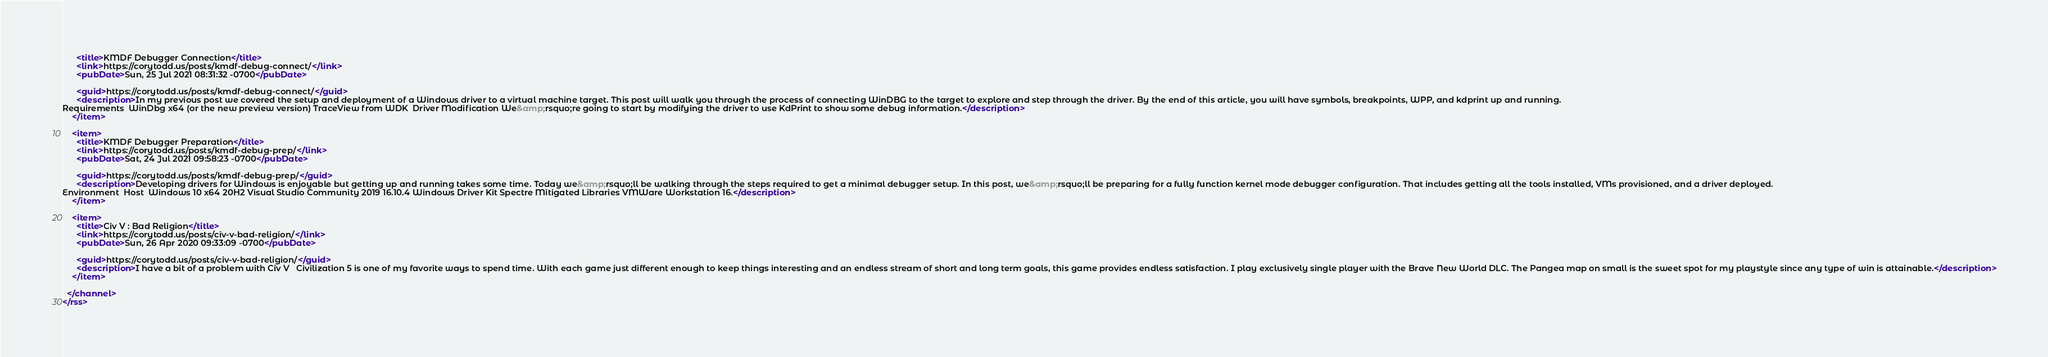<code> <loc_0><loc_0><loc_500><loc_500><_XML_>      <title>KMDF Debugger Connection</title>
      <link>https://corytodd.us/posts/kmdf-debug-connect/</link>
      <pubDate>Sun, 25 Jul 2021 08:31:32 -0700</pubDate>
      
      <guid>https://corytodd.us/posts/kmdf-debug-connect/</guid>
      <description>In my previous post we covered the setup and deployment of a Windows driver to a virtual machine target. This post will walk you through the process of connecting WinDBG to the target to explore and step through the driver. By the end of this article, you will have symbols, breakpoints, WPP, and kdprint up and running.
Requirements  WinDbg x64 (or the new preview version) TraceView from WDK  Driver Modification We&amp;rsquo;re going to start by modifying the driver to use KdPrint to show some debug information.</description>
    </item>
    
    <item>
      <title>KMDF Debugger Preparation</title>
      <link>https://corytodd.us/posts/kmdf-debug-prep/</link>
      <pubDate>Sat, 24 Jul 2021 09:58:23 -0700</pubDate>
      
      <guid>https://corytodd.us/posts/kmdf-debug-prep/</guid>
      <description>Developing drivers for Windows is enjoyable but getting up and running takes some time. Today we&amp;rsquo;ll be walking through the steps required to get a minimal debugger setup. In this post, we&amp;rsquo;ll be preparing for a fully function kernel mode debugger configuration. That includes getting all the tools installed, VMs provisioned, and a driver deployed.
Environment  Host  Windows 10 x64 20H2 Visual Studio Community 2019 16.10.4 Windows Driver Kit Spectre Mitigated Libraries VMWare Workstation 16.</description>
    </item>
    
    <item>
      <title>Civ V : Bad Religion</title>
      <link>https://corytodd.us/posts/civ-v-bad-religion/</link>
      <pubDate>Sun, 26 Apr 2020 09:33:09 -0700</pubDate>
      
      <guid>https://corytodd.us/posts/civ-v-bad-religion/</guid>
      <description>I have a bit of a problem with Civ V   Civilization 5 is one of my favorite ways to spend time. With each game just different enough to keep things interesting and an endless stream of short and long term goals, this game provides endless satisfaction. I play exclusively single player with the Brave New World DLC. The Pangea map on small is the sweet spot for my playstyle since any type of win is attainable.</description>
    </item>
    
  </channel>
</rss>
</code> 